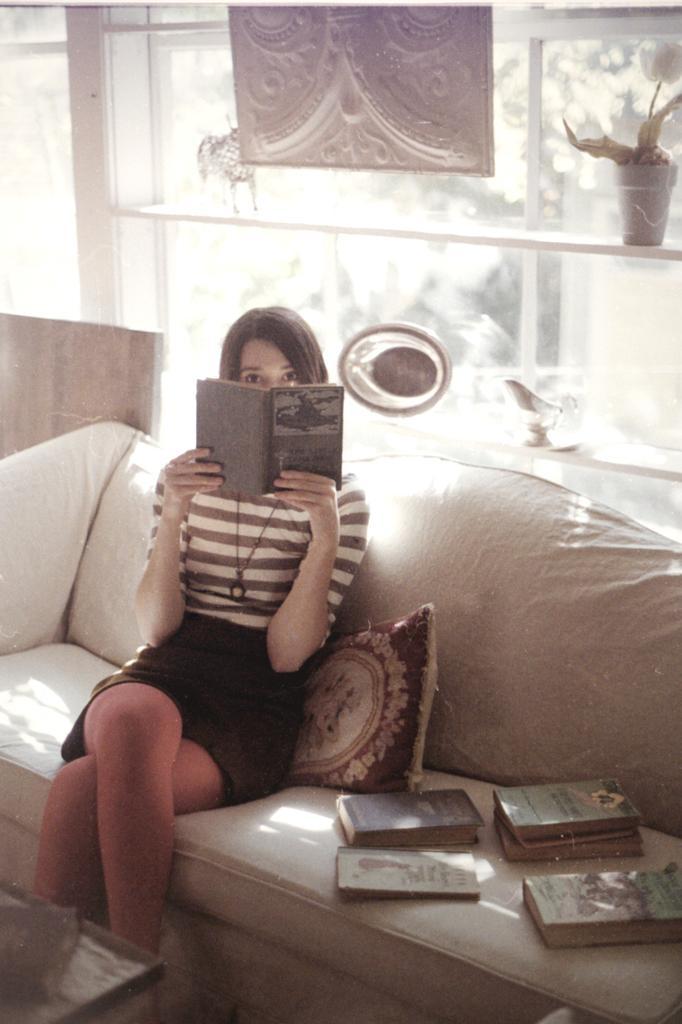Describe this image in one or two sentences. This is a picture of a woman sitting on a couch, the woman is reading a book on the couch there is a pillow and the books , the background of the couch is a glass windows on the table there is a flower pot. 